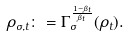Convert formula to latex. <formula><loc_0><loc_0><loc_500><loc_500>\rho _ { \sigma , t } \colon = \Gamma _ { \sigma } ^ { \frac { 1 - \beta _ { t } } { \beta _ { t } } } ( \rho _ { t } ) .</formula> 